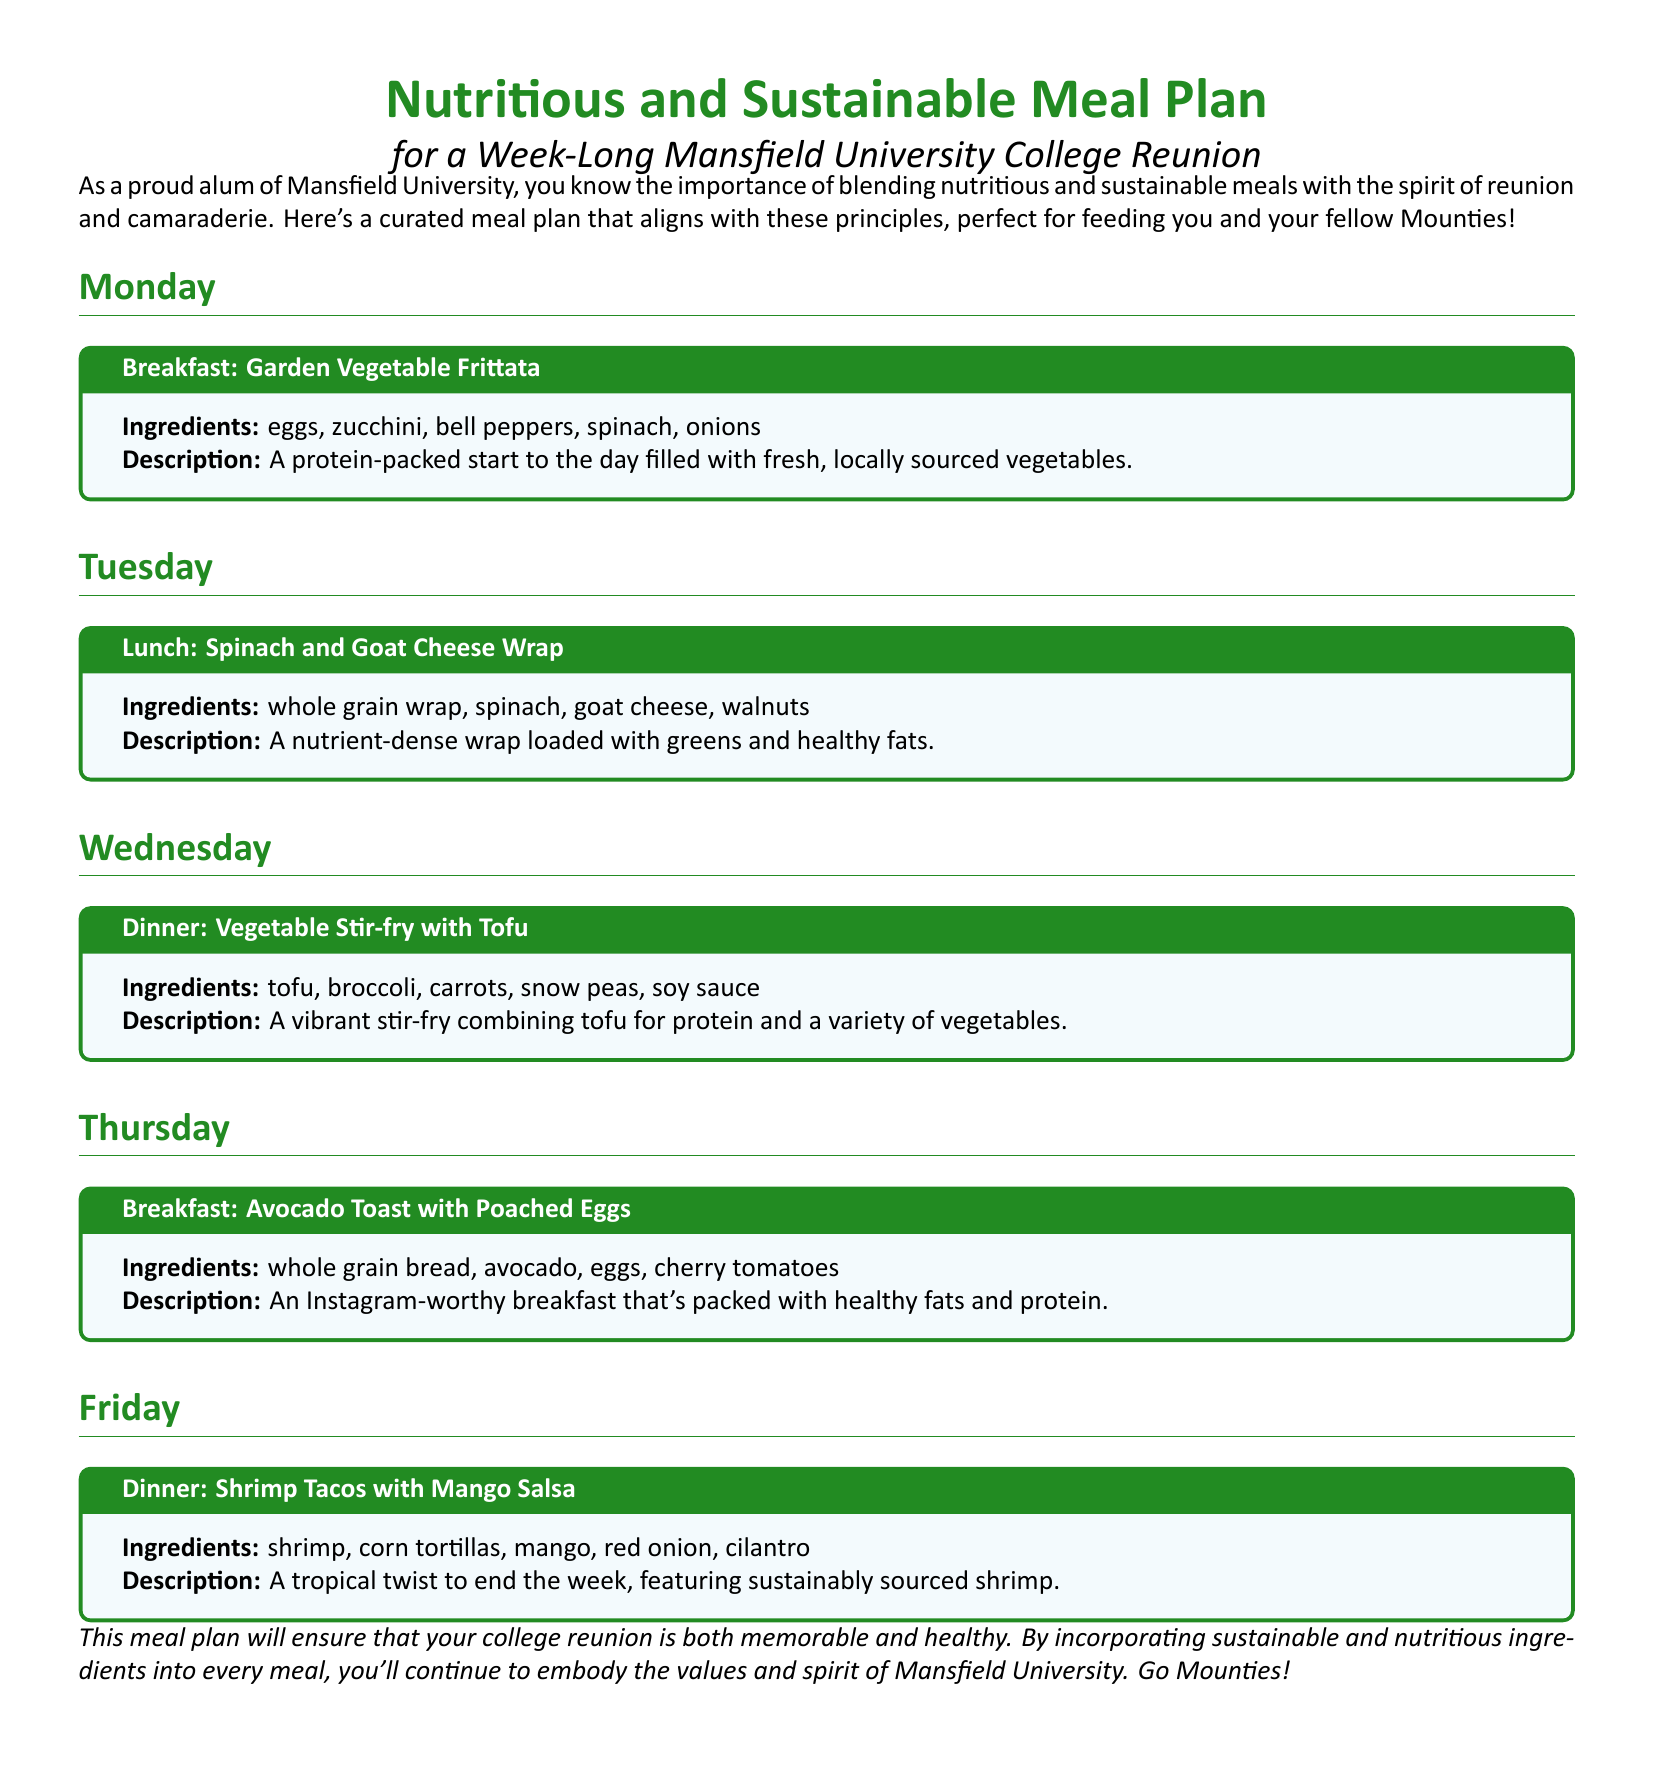What meal is served for breakfast on Monday? The meal served for breakfast on Monday is outlined in the Monday section, indicating a Garden Vegetable Frittata.
Answer: Garden Vegetable Frittata What ingredients are included in the Spinach and Goat Cheese Wrap? The ingredients for the Spinach and Goat Cheese Wrap are listed under the Tuesday section, which include whole grain wrap, spinach, goat cheese, and walnuts.
Answer: whole grain wrap, spinach, goat cheese, walnuts What type of protein is used in the Vegetable Stir-fry with Tofu? The type of protein used in the Vegetable Stir-fry is evident from the Wednesday section, which specifies tofu as the protein source.
Answer: tofu How many meals are listed for the week? The meals for the week are specified in the document, with separate sections for each day, totaling five meals.
Answer: five What day features the dinner with shrimp? The day featuring shrimp tacos for dinner can be found in the Friday section.
Answer: Friday What is the main advantage of the Avocado Toast with Poached Eggs? The advantages are noted in the Thursday section where it mentions being packed with healthy fats and protein.
Answer: healthy fats and protein What kind of tortillas are used in the Shrimp Tacos? The type of tortillas used in the Shrimp Tacos is indicated in the Friday section, mentioning corn tortillas.
Answer: corn tortillas 